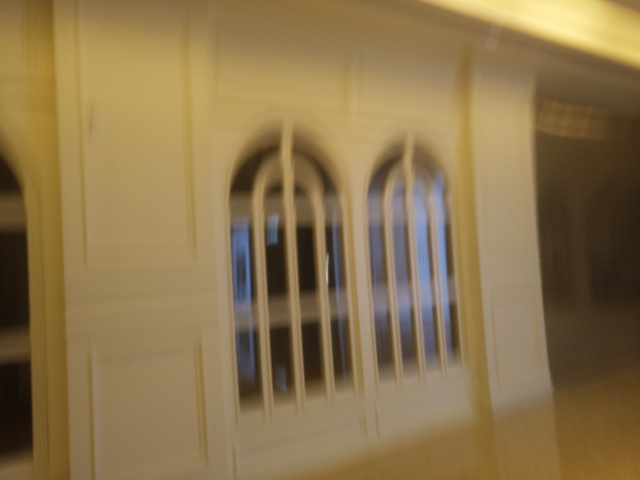Are there any quality issues with this image? Yes, the image appears to be blurry, which affects the clarity and makes it difficult to discern fine details. This issue might be caused by camera motion during the shot, incorrect focus settings, or a low-resolution capture. 